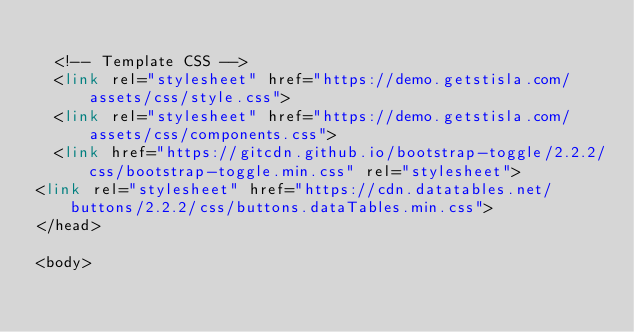Convert code to text. <code><loc_0><loc_0><loc_500><loc_500><_PHP_>
  <!-- Template CSS -->
  <link rel="stylesheet" href="https://demo.getstisla.com/assets/css/style.css">
  <link rel="stylesheet" href="https://demo.getstisla.com/assets/css/components.css">
  <link href="https://gitcdn.github.io/bootstrap-toggle/2.2.2/css/bootstrap-toggle.min.css" rel="stylesheet">
<link rel="stylesheet" href="https://cdn.datatables.net/buttons/2.2.2/css/buttons.dataTables.min.css">
</head>

<body></code> 